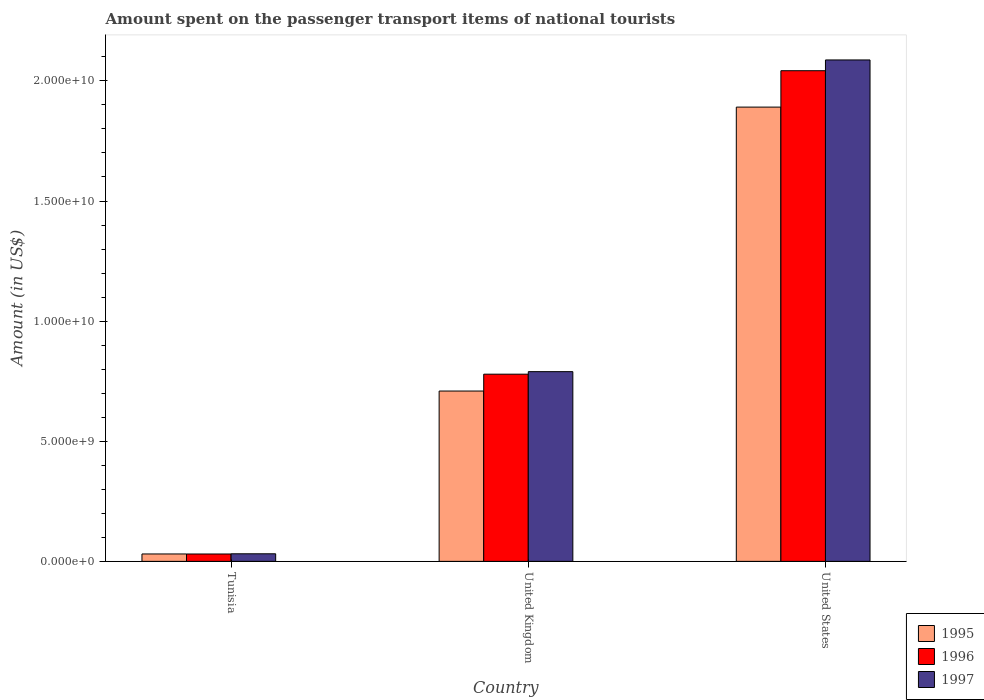How many groups of bars are there?
Provide a succinct answer. 3. Are the number of bars on each tick of the X-axis equal?
Ensure brevity in your answer.  Yes. How many bars are there on the 3rd tick from the right?
Offer a terse response. 3. What is the amount spent on the passenger transport items of national tourists in 1996 in United Kingdom?
Give a very brief answer. 7.79e+09. Across all countries, what is the maximum amount spent on the passenger transport items of national tourists in 1995?
Your answer should be compact. 1.89e+1. Across all countries, what is the minimum amount spent on the passenger transport items of national tourists in 1996?
Your answer should be compact. 3.07e+08. In which country was the amount spent on the passenger transport items of national tourists in 1997 minimum?
Offer a terse response. Tunisia. What is the total amount spent on the passenger transport items of national tourists in 1996 in the graph?
Ensure brevity in your answer.  2.85e+1. What is the difference between the amount spent on the passenger transport items of national tourists in 1996 in Tunisia and that in United States?
Give a very brief answer. -2.01e+1. What is the difference between the amount spent on the passenger transport items of national tourists in 1995 in Tunisia and the amount spent on the passenger transport items of national tourists in 1997 in United Kingdom?
Provide a succinct answer. -7.59e+09. What is the average amount spent on the passenger transport items of national tourists in 1997 per country?
Your answer should be compact. 9.69e+09. What is the difference between the amount spent on the passenger transport items of national tourists of/in 1997 and amount spent on the passenger transport items of national tourists of/in 1995 in United Kingdom?
Make the answer very short. 8.07e+08. What is the ratio of the amount spent on the passenger transport items of national tourists in 1996 in Tunisia to that in United Kingdom?
Your answer should be compact. 0.04. Is the difference between the amount spent on the passenger transport items of national tourists in 1997 in United Kingdom and United States greater than the difference between the amount spent on the passenger transport items of national tourists in 1995 in United Kingdom and United States?
Ensure brevity in your answer.  No. What is the difference between the highest and the second highest amount spent on the passenger transport items of national tourists in 1996?
Offer a terse response. 1.26e+1. What is the difference between the highest and the lowest amount spent on the passenger transport items of national tourists in 1996?
Provide a succinct answer. 2.01e+1. What does the 1st bar from the left in Tunisia represents?
Your answer should be very brief. 1995. How many bars are there?
Provide a short and direct response. 9. Are all the bars in the graph horizontal?
Your answer should be compact. No. How many countries are there in the graph?
Keep it short and to the point. 3. What is the difference between two consecutive major ticks on the Y-axis?
Offer a very short reply. 5.00e+09. Does the graph contain grids?
Make the answer very short. No. What is the title of the graph?
Your answer should be compact. Amount spent on the passenger transport items of national tourists. What is the label or title of the X-axis?
Provide a succinct answer. Country. What is the Amount (in US$) of 1995 in Tunisia?
Your answer should be compact. 3.08e+08. What is the Amount (in US$) of 1996 in Tunisia?
Your answer should be very brief. 3.07e+08. What is the Amount (in US$) in 1997 in Tunisia?
Offer a terse response. 3.15e+08. What is the Amount (in US$) of 1995 in United Kingdom?
Ensure brevity in your answer.  7.09e+09. What is the Amount (in US$) of 1996 in United Kingdom?
Keep it short and to the point. 7.79e+09. What is the Amount (in US$) in 1997 in United Kingdom?
Keep it short and to the point. 7.90e+09. What is the Amount (in US$) in 1995 in United States?
Offer a very short reply. 1.89e+1. What is the Amount (in US$) of 1996 in United States?
Provide a succinct answer. 2.04e+1. What is the Amount (in US$) of 1997 in United States?
Provide a short and direct response. 2.09e+1. Across all countries, what is the maximum Amount (in US$) of 1995?
Your answer should be compact. 1.89e+1. Across all countries, what is the maximum Amount (in US$) in 1996?
Offer a very short reply. 2.04e+1. Across all countries, what is the maximum Amount (in US$) in 1997?
Your response must be concise. 2.09e+1. Across all countries, what is the minimum Amount (in US$) of 1995?
Give a very brief answer. 3.08e+08. Across all countries, what is the minimum Amount (in US$) of 1996?
Your response must be concise. 3.07e+08. Across all countries, what is the minimum Amount (in US$) in 1997?
Offer a very short reply. 3.15e+08. What is the total Amount (in US$) in 1995 in the graph?
Make the answer very short. 2.63e+1. What is the total Amount (in US$) of 1996 in the graph?
Your response must be concise. 2.85e+1. What is the total Amount (in US$) of 1997 in the graph?
Your response must be concise. 2.91e+1. What is the difference between the Amount (in US$) in 1995 in Tunisia and that in United Kingdom?
Offer a very short reply. -6.78e+09. What is the difference between the Amount (in US$) of 1996 in Tunisia and that in United Kingdom?
Provide a short and direct response. -7.48e+09. What is the difference between the Amount (in US$) in 1997 in Tunisia and that in United Kingdom?
Provide a short and direct response. -7.58e+09. What is the difference between the Amount (in US$) in 1995 in Tunisia and that in United States?
Your answer should be compact. -1.86e+1. What is the difference between the Amount (in US$) of 1996 in Tunisia and that in United States?
Your answer should be compact. -2.01e+1. What is the difference between the Amount (in US$) in 1997 in Tunisia and that in United States?
Your answer should be very brief. -2.06e+1. What is the difference between the Amount (in US$) in 1995 in United Kingdom and that in United States?
Provide a succinct answer. -1.18e+1. What is the difference between the Amount (in US$) of 1996 in United Kingdom and that in United States?
Keep it short and to the point. -1.26e+1. What is the difference between the Amount (in US$) of 1997 in United Kingdom and that in United States?
Your answer should be very brief. -1.30e+1. What is the difference between the Amount (in US$) of 1995 in Tunisia and the Amount (in US$) of 1996 in United Kingdom?
Your response must be concise. -7.48e+09. What is the difference between the Amount (in US$) of 1995 in Tunisia and the Amount (in US$) of 1997 in United Kingdom?
Your response must be concise. -7.59e+09. What is the difference between the Amount (in US$) of 1996 in Tunisia and the Amount (in US$) of 1997 in United Kingdom?
Offer a terse response. -7.59e+09. What is the difference between the Amount (in US$) of 1995 in Tunisia and the Amount (in US$) of 1996 in United States?
Give a very brief answer. -2.01e+1. What is the difference between the Amount (in US$) of 1995 in Tunisia and the Amount (in US$) of 1997 in United States?
Provide a short and direct response. -2.06e+1. What is the difference between the Amount (in US$) of 1996 in Tunisia and the Amount (in US$) of 1997 in United States?
Offer a very short reply. -2.06e+1. What is the difference between the Amount (in US$) of 1995 in United Kingdom and the Amount (in US$) of 1996 in United States?
Offer a very short reply. -1.33e+1. What is the difference between the Amount (in US$) in 1995 in United Kingdom and the Amount (in US$) in 1997 in United States?
Ensure brevity in your answer.  -1.38e+1. What is the difference between the Amount (in US$) of 1996 in United Kingdom and the Amount (in US$) of 1997 in United States?
Your answer should be compact. -1.31e+1. What is the average Amount (in US$) of 1995 per country?
Provide a succinct answer. 8.77e+09. What is the average Amount (in US$) in 1996 per country?
Your answer should be compact. 9.51e+09. What is the average Amount (in US$) in 1997 per country?
Ensure brevity in your answer.  9.69e+09. What is the difference between the Amount (in US$) of 1995 and Amount (in US$) of 1996 in Tunisia?
Provide a short and direct response. 1.00e+06. What is the difference between the Amount (in US$) in 1995 and Amount (in US$) in 1997 in Tunisia?
Your answer should be compact. -7.00e+06. What is the difference between the Amount (in US$) in 1996 and Amount (in US$) in 1997 in Tunisia?
Keep it short and to the point. -8.00e+06. What is the difference between the Amount (in US$) of 1995 and Amount (in US$) of 1996 in United Kingdom?
Your response must be concise. -7.02e+08. What is the difference between the Amount (in US$) of 1995 and Amount (in US$) of 1997 in United Kingdom?
Your answer should be very brief. -8.07e+08. What is the difference between the Amount (in US$) of 1996 and Amount (in US$) of 1997 in United Kingdom?
Offer a terse response. -1.05e+08. What is the difference between the Amount (in US$) of 1995 and Amount (in US$) of 1996 in United States?
Your answer should be compact. -1.52e+09. What is the difference between the Amount (in US$) in 1995 and Amount (in US$) in 1997 in United States?
Offer a terse response. -1.96e+09. What is the difference between the Amount (in US$) of 1996 and Amount (in US$) of 1997 in United States?
Make the answer very short. -4.48e+08. What is the ratio of the Amount (in US$) of 1995 in Tunisia to that in United Kingdom?
Your answer should be compact. 0.04. What is the ratio of the Amount (in US$) in 1996 in Tunisia to that in United Kingdom?
Provide a short and direct response. 0.04. What is the ratio of the Amount (in US$) of 1997 in Tunisia to that in United Kingdom?
Your response must be concise. 0.04. What is the ratio of the Amount (in US$) of 1995 in Tunisia to that in United States?
Make the answer very short. 0.02. What is the ratio of the Amount (in US$) in 1996 in Tunisia to that in United States?
Your answer should be very brief. 0.01. What is the ratio of the Amount (in US$) in 1997 in Tunisia to that in United States?
Make the answer very short. 0.02. What is the ratio of the Amount (in US$) of 1996 in United Kingdom to that in United States?
Your response must be concise. 0.38. What is the ratio of the Amount (in US$) in 1997 in United Kingdom to that in United States?
Ensure brevity in your answer.  0.38. What is the difference between the highest and the second highest Amount (in US$) in 1995?
Your answer should be very brief. 1.18e+1. What is the difference between the highest and the second highest Amount (in US$) of 1996?
Your response must be concise. 1.26e+1. What is the difference between the highest and the second highest Amount (in US$) in 1997?
Provide a short and direct response. 1.30e+1. What is the difference between the highest and the lowest Amount (in US$) of 1995?
Your answer should be very brief. 1.86e+1. What is the difference between the highest and the lowest Amount (in US$) of 1996?
Provide a short and direct response. 2.01e+1. What is the difference between the highest and the lowest Amount (in US$) in 1997?
Your answer should be very brief. 2.06e+1. 